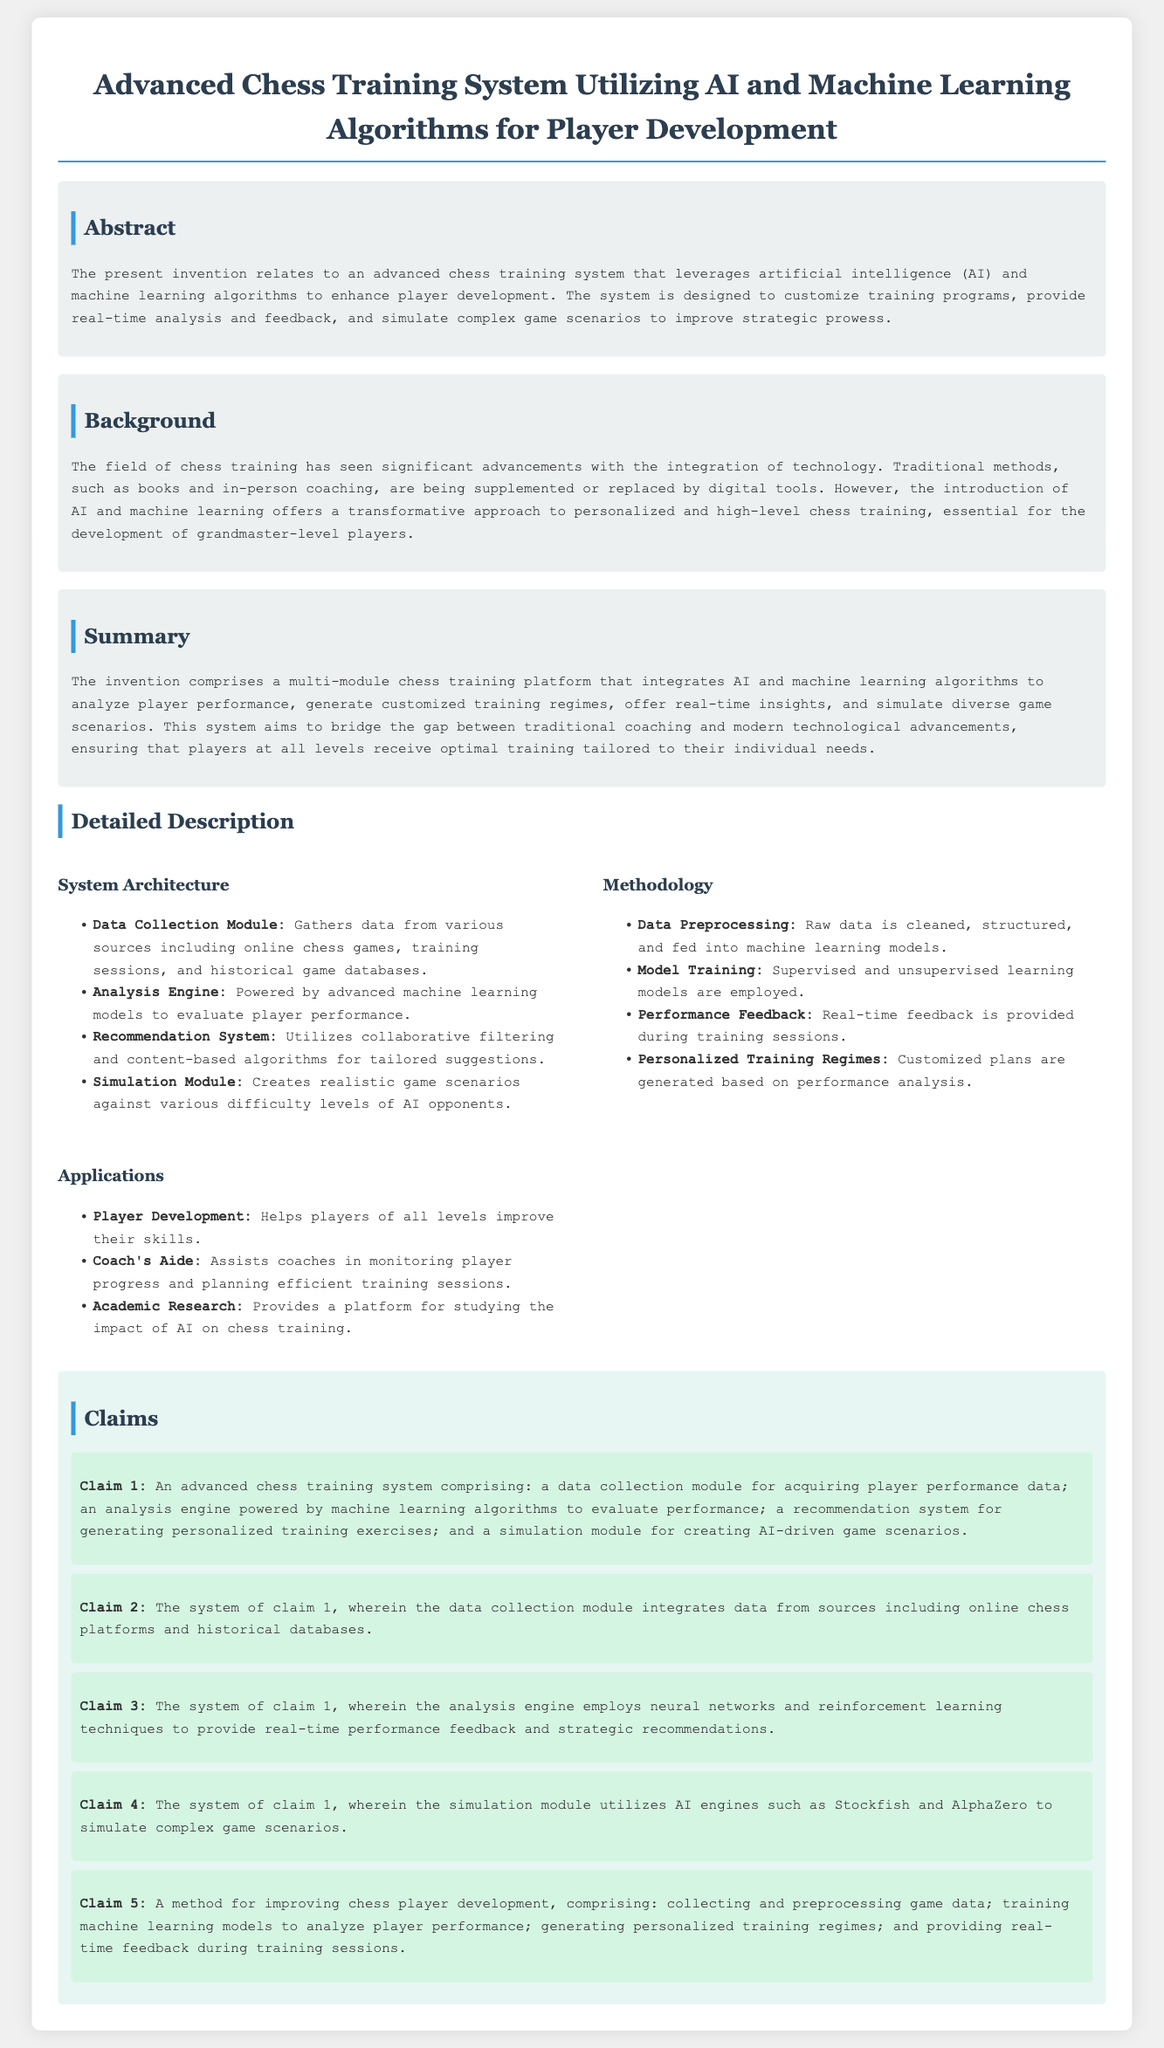what is the title of the patent application? The title of the patent application is stated at the top of the document.
Answer: Advanced Chess Training System Utilizing AI and Machine Learning Algorithms for Player Development what technology does the training system utilize? The document indicates the technologies integrated into the training system.
Answer: AI and machine learning algorithms what is the primary goal of the advanced chess training system? The abstract section outlines the main objective of the invention.
Answer: Enhance player development how many claims are included in the patent application? The claims section lists the claims made in the application.
Answer: Five what does the recommendation system use to generate training suggestions? This information is found under the system architecture description.
Answer: Collaborative filtering and content-based algorithms what is the purpose of the simulation module? The purpose is described in the system architecture section, detailing its functions.
Answer: Creates realistic game scenarios which method is utilized for model training? The methodology section specifies the approach taken for training.
Answer: Supervised and unsupervised learning models who can benefit from the applications of the system? The applications section describes the various beneficiaries of the system.
Answer: Players of all levels, coaches, academic researchers what does the analysis engine evaluate? The functionality of the analysis engine is presented in the system architecture.
Answer: Player performance 